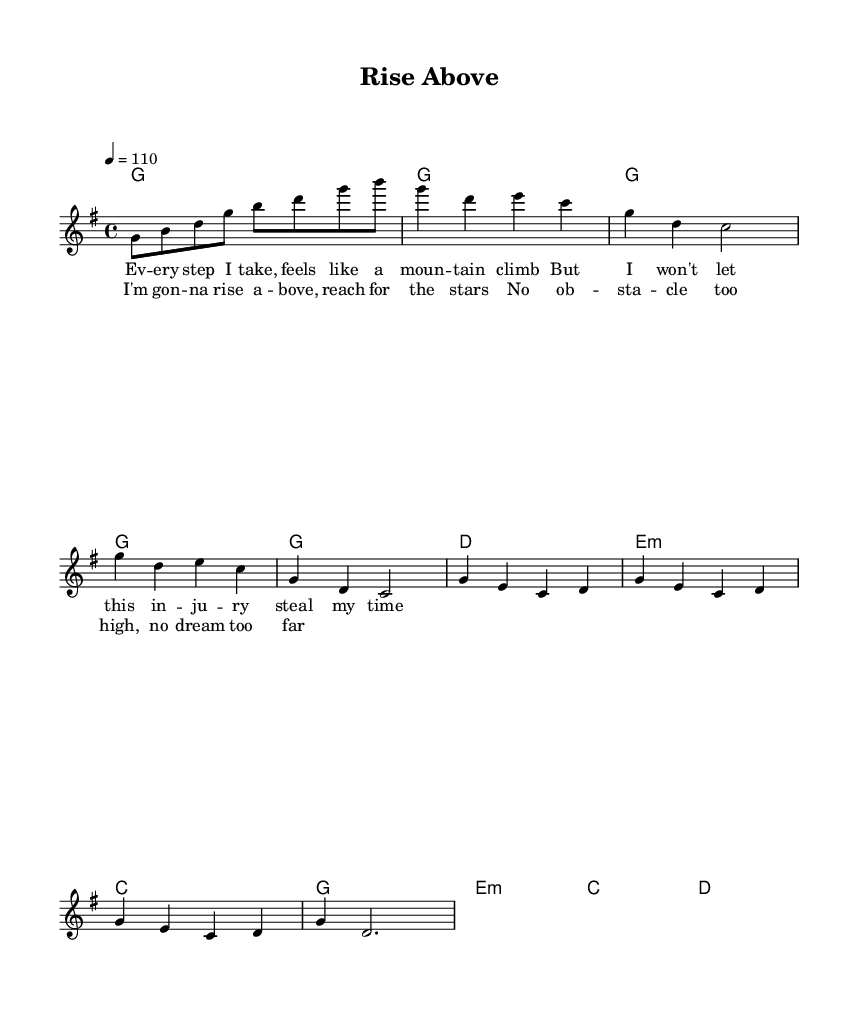What is the key signature of this music? The key signature is G major, which consists of one sharp (F#). This is identified from the key indication at the beginning of the score.
Answer: G major What is the time signature of this music? The time signature is four-four, as indicated at the beginning of the score. This means there are four beats in each measure and the quarter note gets one beat.
Answer: Four-four What is the tempo marking of this piece? The tempo marking is quarter note equals 110, meaning the piece should be played at a moderate pace of 110 beats per minute, which is indicated at the beginning of the score.
Answer: 110 How many measures are there in the chorus? The chorus consists of four measures, which can be counted by looking at the sections labeled in the melody and harmonies.
Answer: Four What is the final note of the melody in the chorus? The last note of the melody in the chorus is a dotted half note G, which can be observed at the end of the chorus section in the sheet music.
Answer: G What theme is expressed in the lyrics of the first verse? The theme in the lyrics of the first verse is overcoming challenges, as they mention climbing mountains and not allowing injury to steal time, which indicates a struggle against adversity.
Answer: Overcoming challenges What unique element characterizes the Rhythm and Blues genre in this piece? The unique element in this piece is the soulful expressiveness in the melody and lyrics, focusing on personal struggle and aspiration, which is characteristic of Rhythm and Blues music.
Answer: Soulful expressiveness 